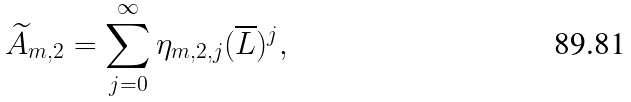<formula> <loc_0><loc_0><loc_500><loc_500>\widetilde { A } _ { m , 2 } = \sum _ { j = 0 } ^ { \infty } \eta _ { m , 2 , j } ( \overline { L } ) ^ { j } ,</formula> 